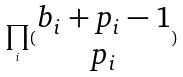<formula> <loc_0><loc_0><loc_500><loc_500>\prod _ { i } ( \begin{matrix} b _ { i } + p _ { i } - 1 \\ p _ { i } \end{matrix} )</formula> 